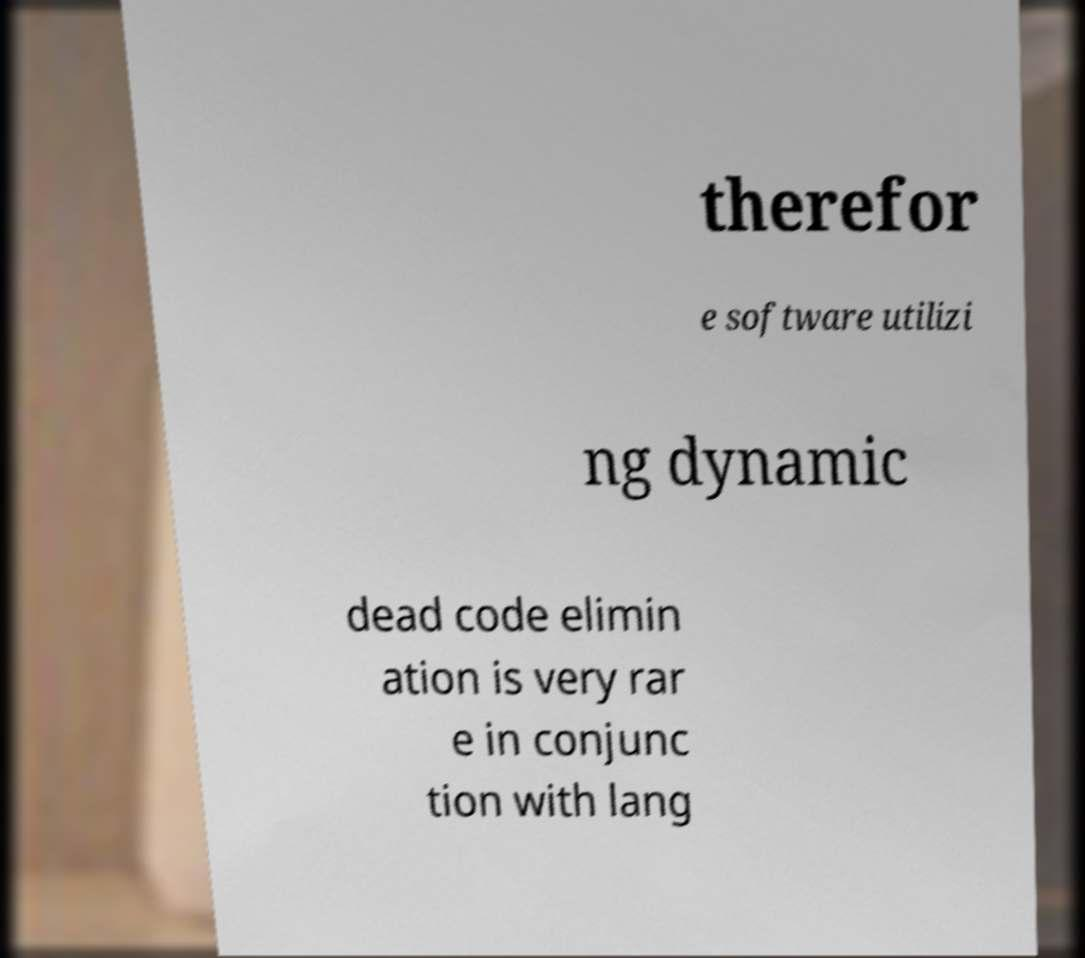What messages or text are displayed in this image? I need them in a readable, typed format. therefor e software utilizi ng dynamic dead code elimin ation is very rar e in conjunc tion with lang 